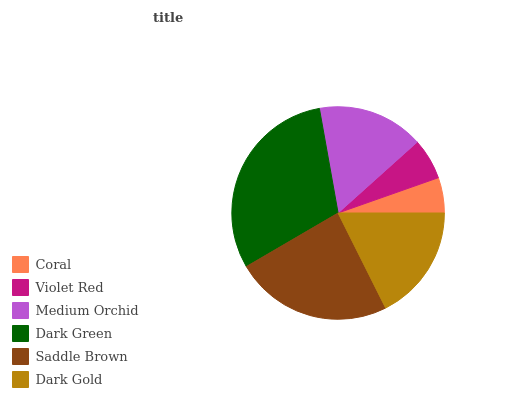Is Coral the minimum?
Answer yes or no. Yes. Is Dark Green the maximum?
Answer yes or no. Yes. Is Violet Red the minimum?
Answer yes or no. No. Is Violet Red the maximum?
Answer yes or no. No. Is Violet Red greater than Coral?
Answer yes or no. Yes. Is Coral less than Violet Red?
Answer yes or no. Yes. Is Coral greater than Violet Red?
Answer yes or no. No. Is Violet Red less than Coral?
Answer yes or no. No. Is Dark Gold the high median?
Answer yes or no. Yes. Is Medium Orchid the low median?
Answer yes or no. Yes. Is Coral the high median?
Answer yes or no. No. Is Coral the low median?
Answer yes or no. No. 